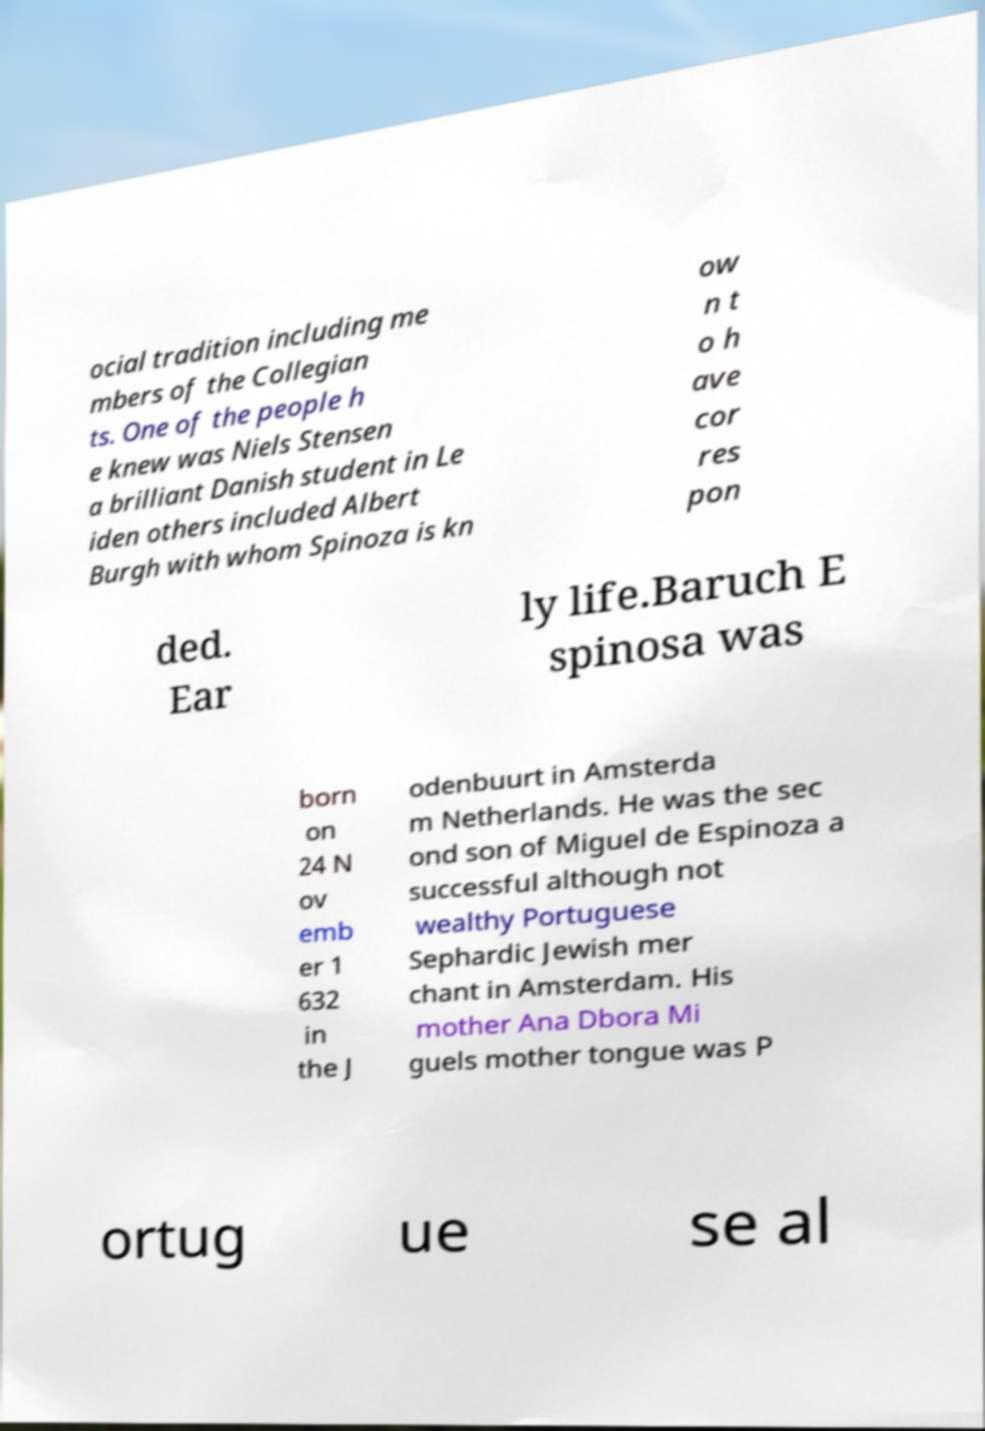Could you extract and type out the text from this image? ocial tradition including me mbers of the Collegian ts. One of the people h e knew was Niels Stensen a brilliant Danish student in Le iden others included Albert Burgh with whom Spinoza is kn ow n t o h ave cor res pon ded. Ear ly life.Baruch E spinosa was born on 24 N ov emb er 1 632 in the J odenbuurt in Amsterda m Netherlands. He was the sec ond son of Miguel de Espinoza a successful although not wealthy Portuguese Sephardic Jewish mer chant in Amsterdam. His mother Ana Dbora Mi guels mother tongue was P ortug ue se al 